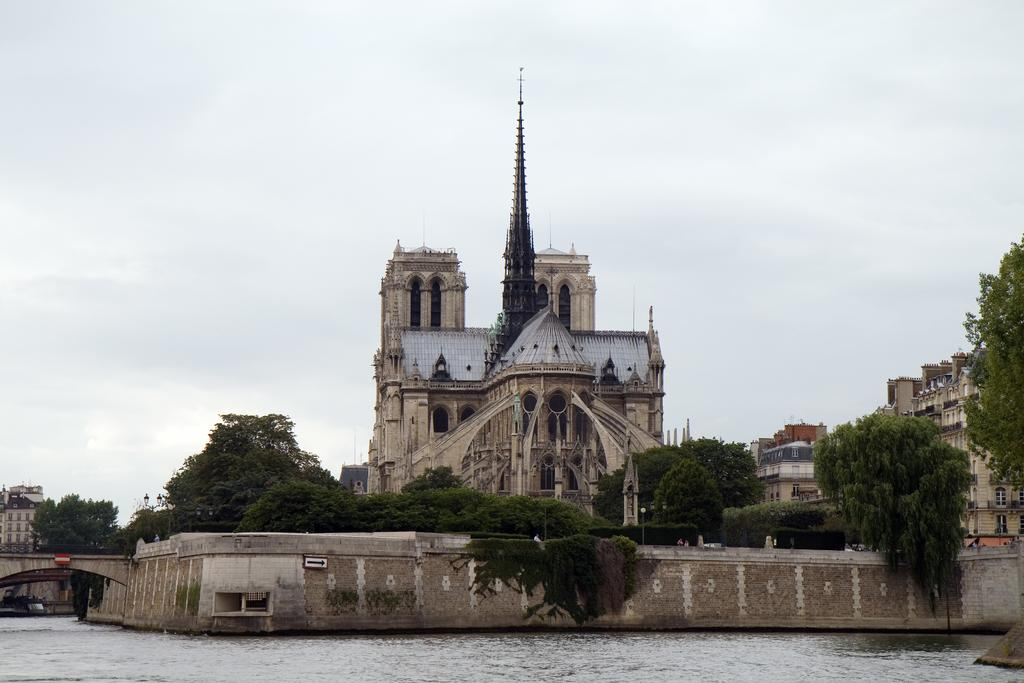What type of structures can be seen in the image? There are buildings in the image. What is located in front of the buildings? There are trees and a wall in front of the buildings. Can you describe any other features in the image? There is a bridge in the image, and water is visible. What can be seen in the sky? The sky is visible in the image. Where is the stranger sitting on the throne in the image? There is no stranger or throne present in the image. What type of sport is being played on the baseball field in the image? There is no baseball field or sport being played in the image. 